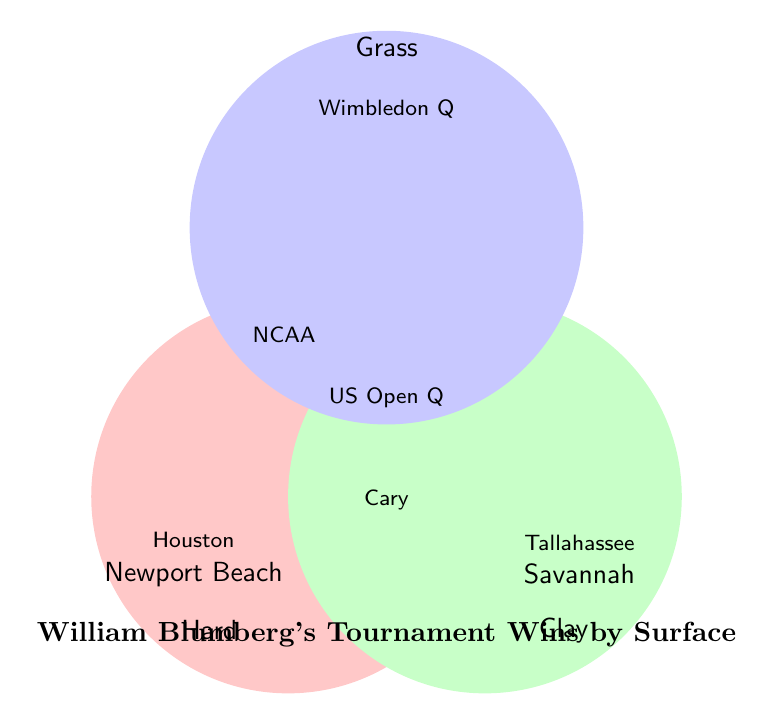What surfaces has William Blumberg won tournaments on? The three-colored circles labeled "Hard," "Clay," and "Grass" represent surfaces where he has won tournaments.
Answer: Hard, Clay, Grass How many tournaments has William Blumberg won on hard courts? Within the "Hard" circle, there are two tournaments listed: Houston and Newport Beach.
Answer: 2 Which tournament is listed at the intersection of hard and clay surfaces? The intersection of the "Hard" and "Clay" circles lists the tournament: Cary.
Answer: Cary What is the title of the Venn Diagram? The title is located at the bottom of the figure: "William Blumberg's Tournament Wins by Surface."
Answer: William Blumberg's Tournament Wins by Surface Which surface has the least number of unique tournaments? The Grass circle lists only one unique tournament: Wimbledon Qualifying.
Answer: Grass Which tournament appears on all three surfaces? In the intersection of all three circles, the middle section lists the US Open Qualifying.
Answer: US Open Qualifying How many tournaments has Blumberg won in total? Adding up the unique tournaments: 2 (Hard) + 2 (Clay) + 1 (Grass) + 1 (Hard/Clay) + 1 (Hard/Grass) + 1 (Hard/Clay/Grass) = 8.
Answer: 8 Where is the NCAA Division I Championships tournament listed? The intersection of hard and grass circles shows NCAA Division I Championships.
Answer: Hard and Grass Which surfaces intersect at the Cary tournament? The Cary tournament is at the intersection of "Hard" and "Clay" circles.
Answer: Hard and Clay Are there any tournaments that Blumberg has won only on clay? Yes, the tournaments listed in the clay circle alone are Tallahassee and Savannah.
Answer: Yes 